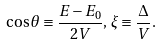Convert formula to latex. <formula><loc_0><loc_0><loc_500><loc_500>\cos \theta \equiv \frac { E - E _ { 0 } } { 2 V } , \, \xi \equiv \frac { \Delta } { V } .</formula> 